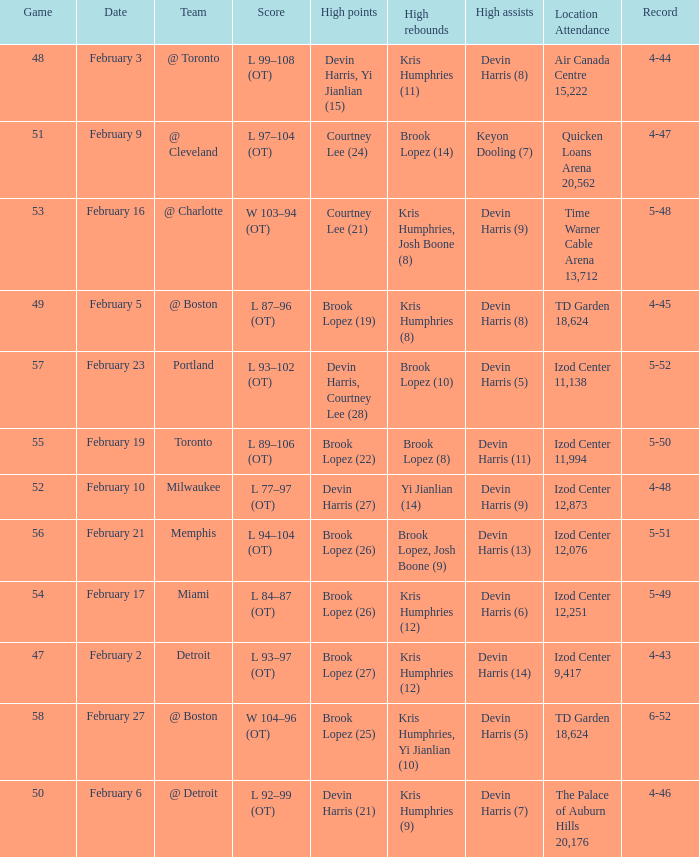Who did the high assists in the game played on February 9? Keyon Dooling (7). 